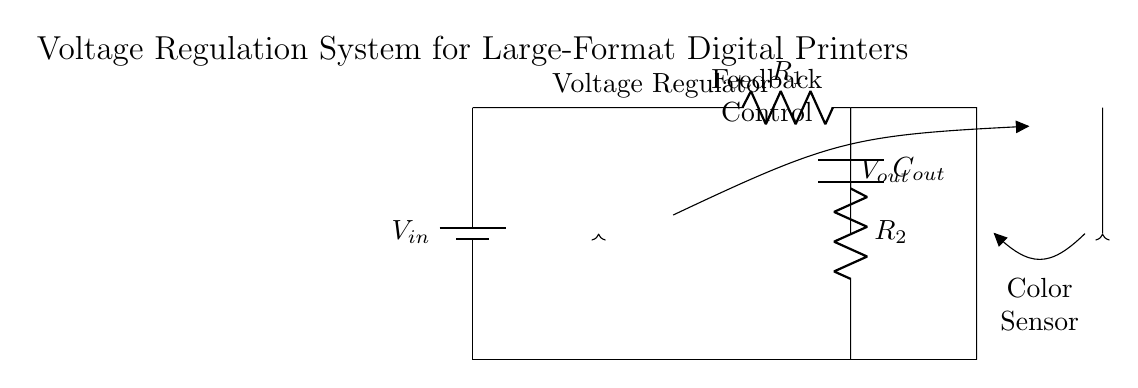What is the type of voltage regulator used in this circuit? The circuit diagram indicates that an LM317 voltage regulator is used, as specified in the label attached to the component.
Answer: LM317 What components are used to adjust the output voltage? The circuit includes two resistors, labeled R1 and R2, which are used in conjunction with the voltage regulator to set the output voltage level.
Answer: R1, R2 What is the purpose of the capacitor in this circuit? The capacitor, labeled Cout, is placed in the circuit to stabilize the output voltage by filtering any fluctuations and ensuring a smooth power supply to the digital printer.
Answer: Stabilizing output voltage How does the color calibration feedback work in this circuit? Feedback from the color sensor is sent to the feedback control, which likely adjusts the voltage output based on the sensor's readings, thereby maintaining precise color calibration for printing.
Answer: Adjust voltage output What is the primary load connected to this voltage regulation system? The primary load in this circuit is the digital printer, which requires a stable voltage supply for its operation.
Answer: Digital printer Which component receives feedback from a color sensor? The color sensor provides feedback directly to the feedback control, which indicates that it monitors the printing colors to ensure they match the intended design.
Answer: Feedback control 